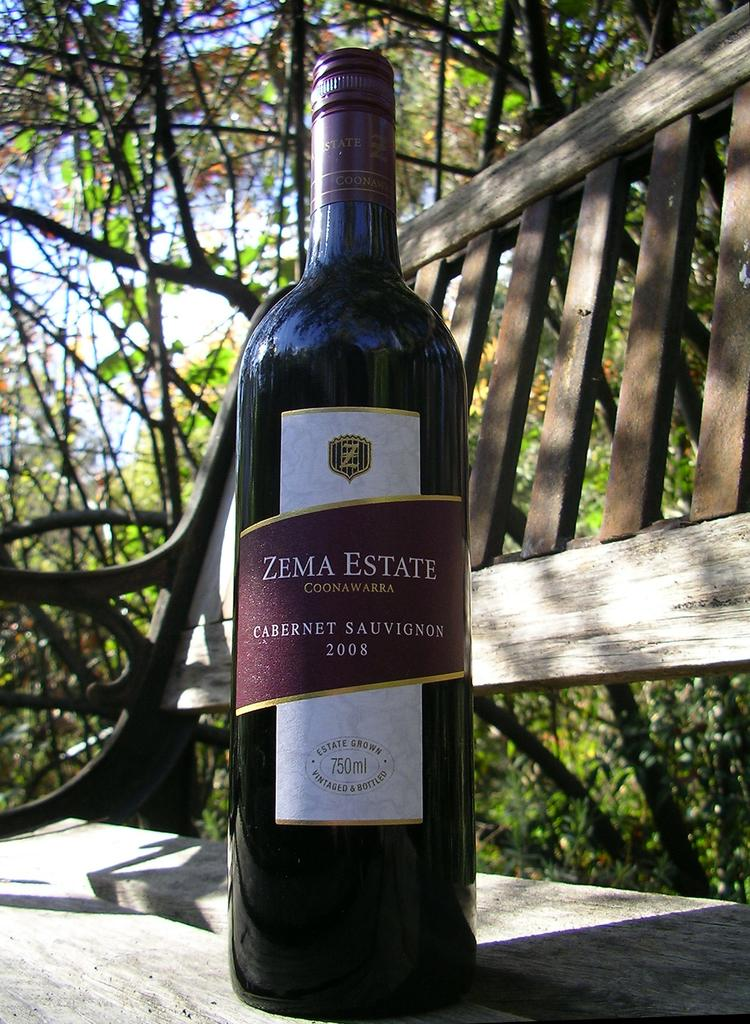Provide a one-sentence caption for the provided image. A bottle is dated 2008 and has the Zema Estate brand logo. 